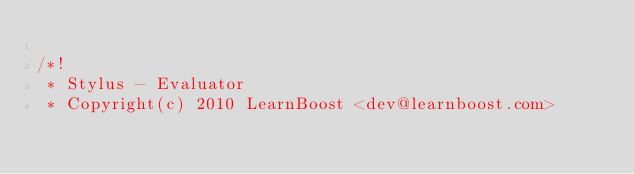<code> <loc_0><loc_0><loc_500><loc_500><_JavaScript_>
/*!
 * Stylus - Evaluator
 * Copyright(c) 2010 LearnBoost <dev@learnboost.com></code> 